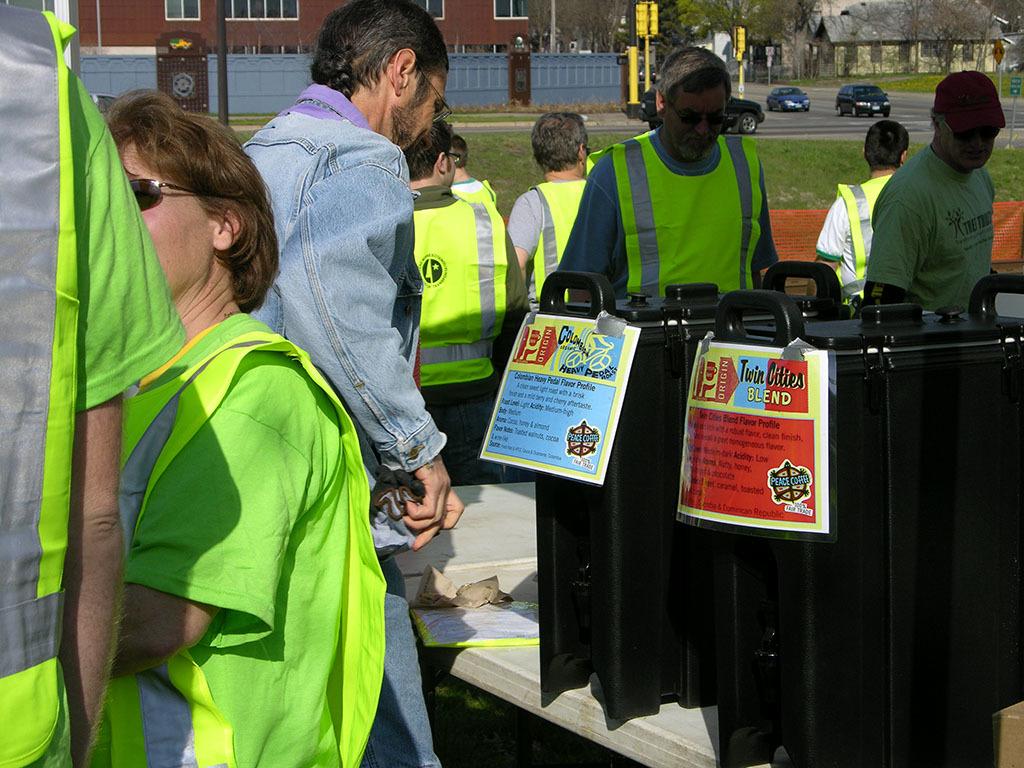What kind of blend is in the container on the right?
Offer a terse response. Twin cities. 